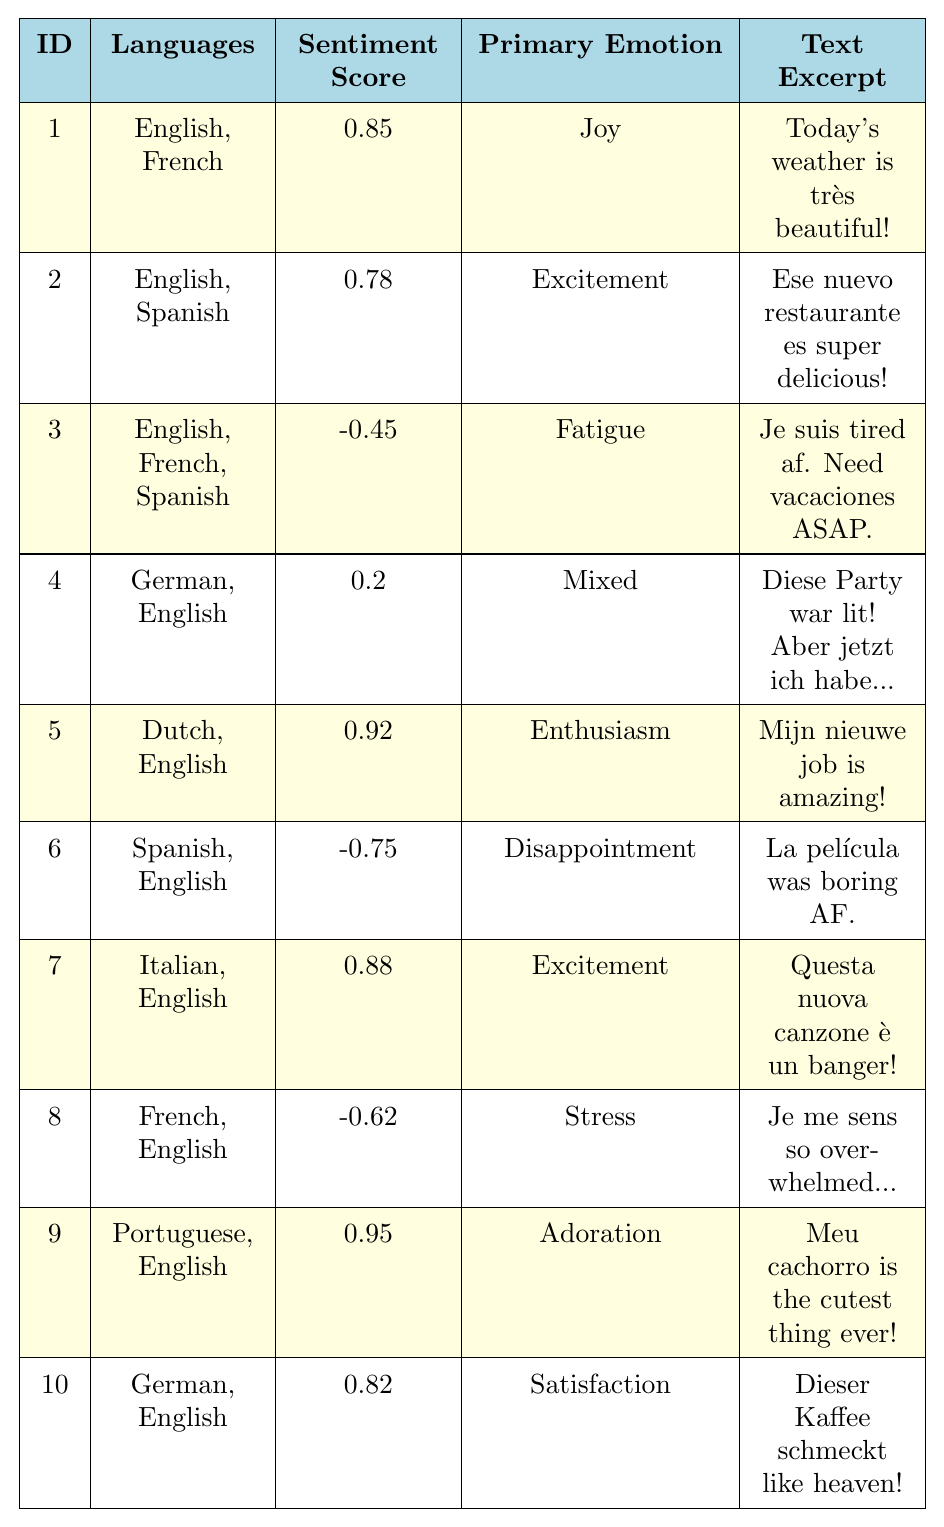What is the sentiment score of the post with ID 5? The sentiment score for the post with ID 5 is explicitly listed in the table, which shows that it is 0.92.
Answer: 0.92 Which languages are used in the post with ID 3? The languages for the post with ID 3 are specified in the table, listed as English, French, and Spanish.
Answer: English, French, Spanish Is the primary emotion for post ID 6 "disappointment"? The table shows the primary emotion for post ID 6, which is noted as "disappointment," confirming that this statement is true.
Answer: Yes What is the highest sentiment score among all posts? By examining the sentiment scores in the table, the highest score is 0.95 from post ID 9.
Answer: 0.95 How many posts have a sentiment score greater than 0? A count of posts with sentiment scores greater than 0 shows that posts ID 1, 2, 5, 7, 9, and 10 have positive scores, totaling 6 posts.
Answer: 6 Which post has the lowest sentiment score, and what is it? The post with ID 6 has the lowest sentiment score of -0.75, as indicated in the table.
Answer: Post ID 6 with a score of -0.75 What languages are present in the post with the second highest sentiment score? The second highest sentiment score is 0.92 (post ID 5), which features the languages Dutch and English.
Answer: Dutch, English How many posts express "joy" as the primary emotion? By reviewing the entries, the posts with ID 1 is the only one that expresses "joy," so only one post fits this criteria.
Answer: 1 Are there more posts written in English than in any other single language? Each post includes English, and analyzing the table shows that all but one post (ID 4) features English, confirming that it is present in the majority of the entries.
Answer: Yes What is the average sentiment score for posts that include Spanish? The posts with Spanish (IDs 2, 3, 6) have scores of 0.78, -0.45, and -0.75. Summing these gives -0.42, and dividing by 3 yields an average score of -0.14.
Answer: -0.14 